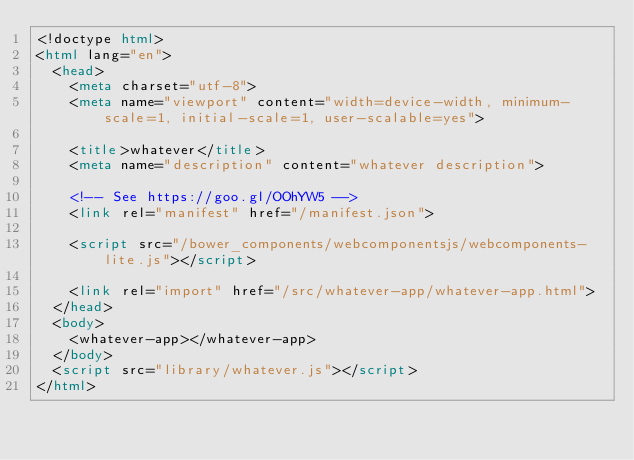Convert code to text. <code><loc_0><loc_0><loc_500><loc_500><_HTML_><!doctype html>
<html lang="en">
  <head>
    <meta charset="utf-8">
    <meta name="viewport" content="width=device-width, minimum-scale=1, initial-scale=1, user-scalable=yes">

    <title>whatever</title>
    <meta name="description" content="whatever description">

    <!-- See https://goo.gl/OOhYW5 -->
    <link rel="manifest" href="/manifest.json">

    <script src="/bower_components/webcomponentsjs/webcomponents-lite.js"></script>

    <link rel="import" href="/src/whatever-app/whatever-app.html">
  </head>
  <body>
    <whatever-app></whatever-app>
  </body>
  <script src="library/whatever.js"></script>
</html>
</code> 